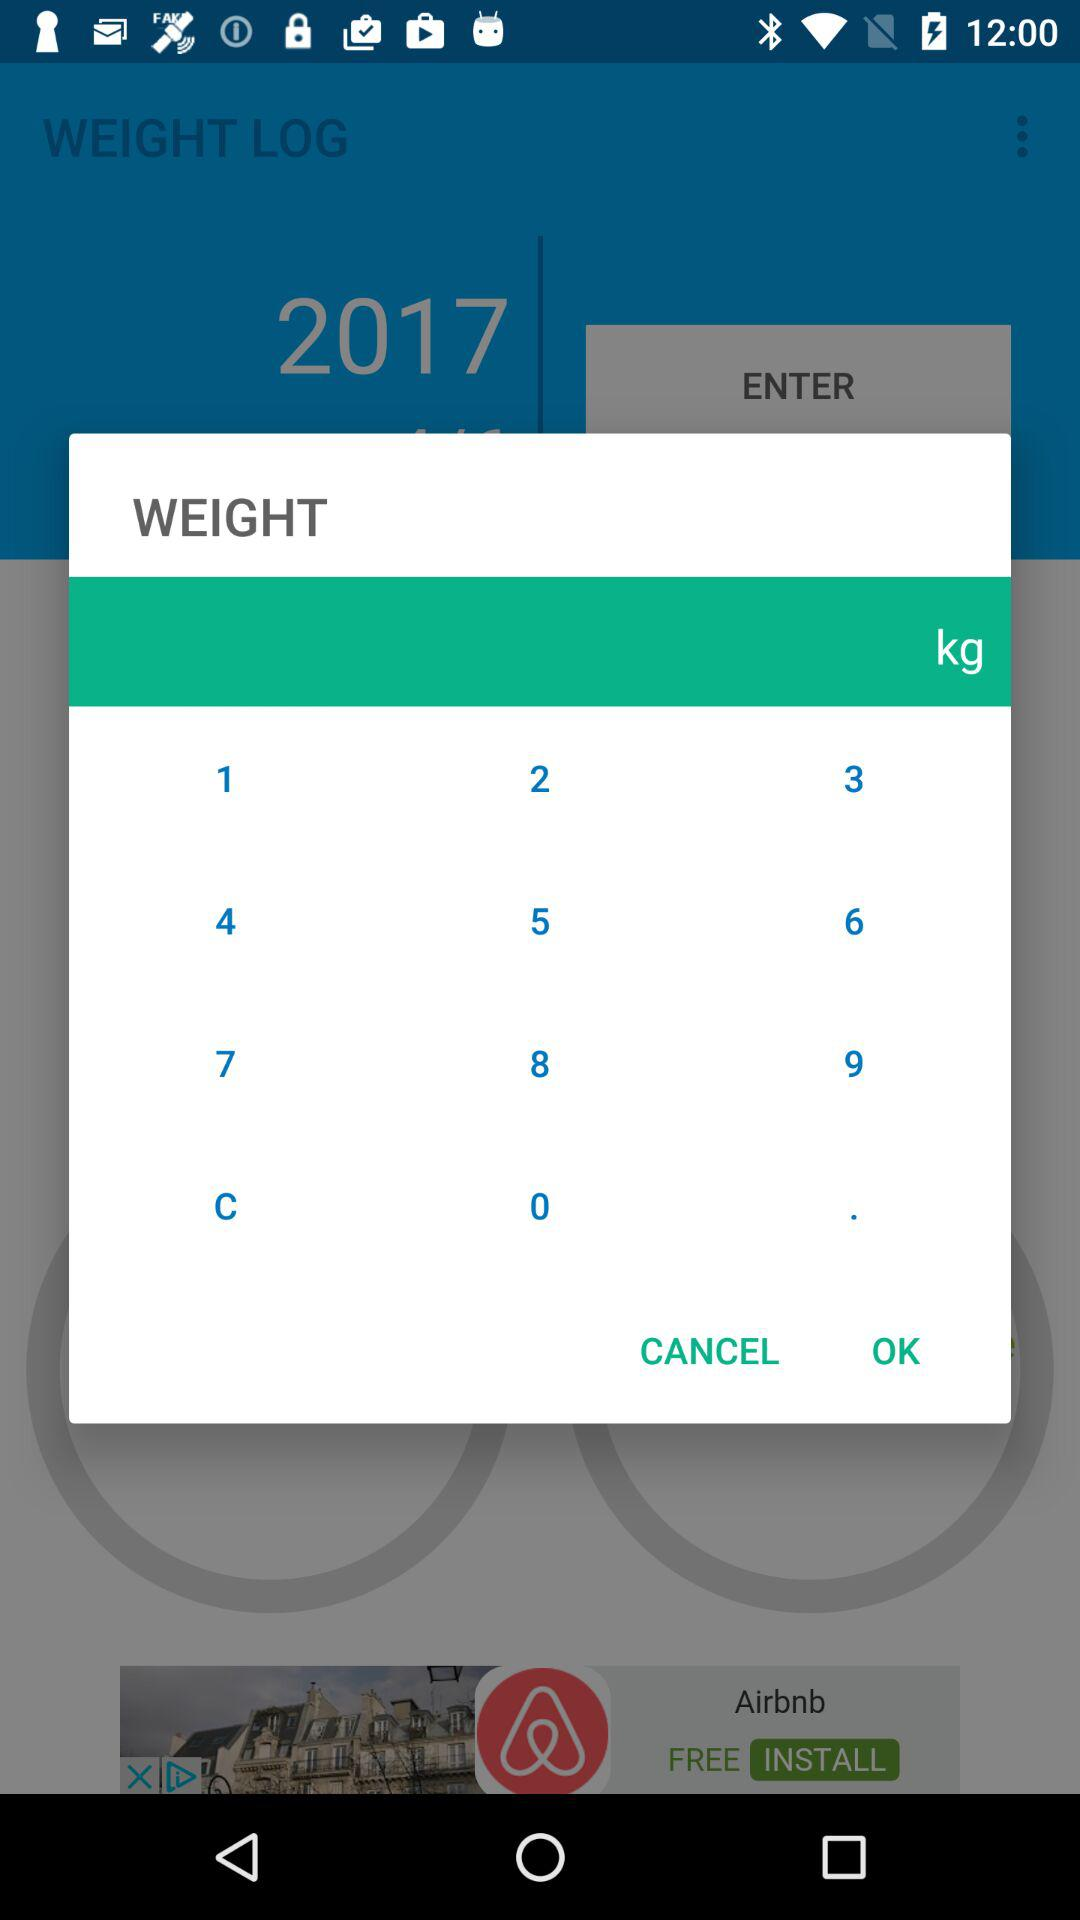What year is mentioned in the application? The mentioned year is 2017. 